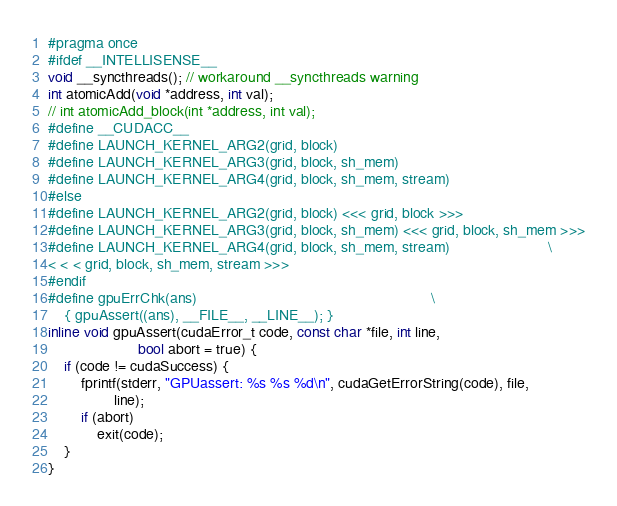<code> <loc_0><loc_0><loc_500><loc_500><_Cuda_>#pragma once
#ifdef __INTELLISENSE__
void __syncthreads(); // workaround __syncthreads warning
int atomicAdd(void *address, int val);
// int atomicAdd_block(int *address, int val);
#define __CUDACC__
#define LAUNCH_KERNEL_ARG2(grid, block)
#define LAUNCH_KERNEL_ARG3(grid, block, sh_mem)
#define LAUNCH_KERNEL_ARG4(grid, block, sh_mem, stream)
#else
#define LAUNCH_KERNEL_ARG2(grid, block) <<< grid, block >>>
#define LAUNCH_KERNEL_ARG3(grid, block, sh_mem) <<< grid, block, sh_mem >>>
#define LAUNCH_KERNEL_ARG4(grid, block, sh_mem, stream)                        \
< < < grid, block, sh_mem, stream >>>
#endif
#define gpuErrChk(ans)                                                         \
    { gpuAssert((ans), __FILE__, __LINE__); }
inline void gpuAssert(cudaError_t code, const char *file, int line,
                      bool abort = true) {
    if (code != cudaSuccess) {
        fprintf(stderr, "GPUassert: %s %s %d\n", cudaGetErrorString(code), file,
                line);
        if (abort)
            exit(code);
    }
}
</code> 